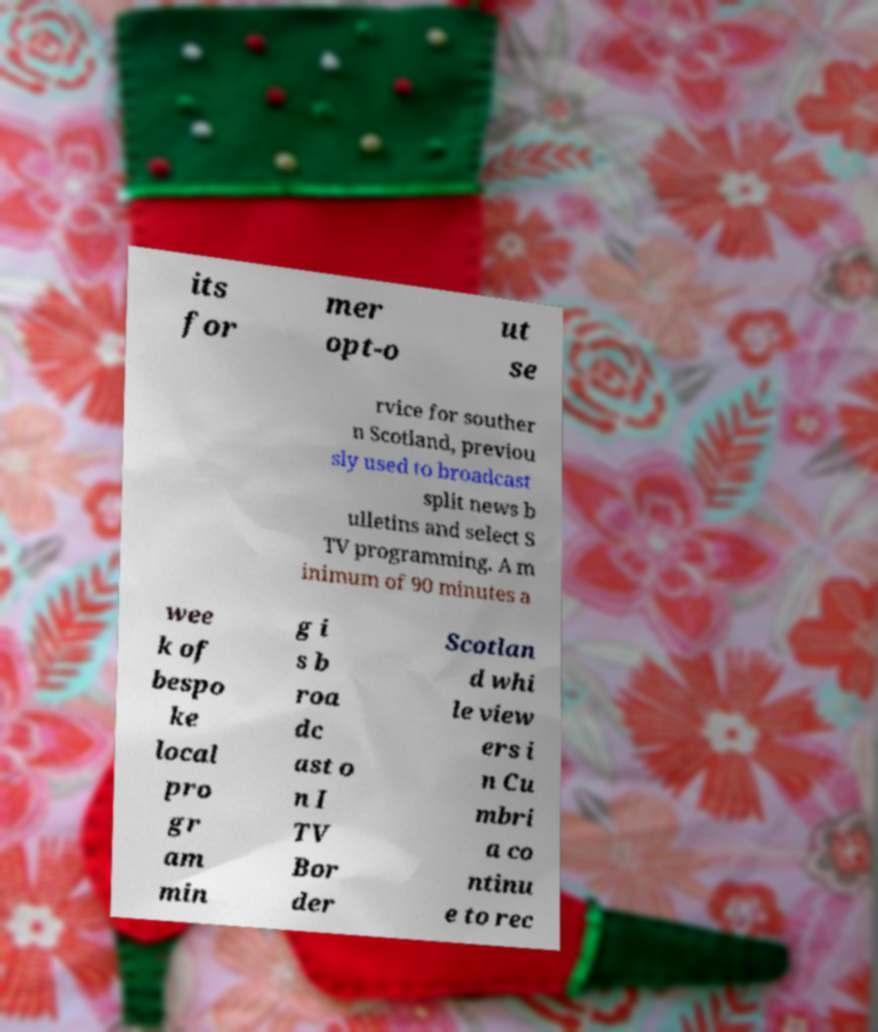Can you read and provide the text displayed in the image?This photo seems to have some interesting text. Can you extract and type it out for me? its for mer opt-o ut se rvice for souther n Scotland, previou sly used to broadcast split news b ulletins and select S TV programming. A m inimum of 90 minutes a wee k of bespo ke local pro gr am min g i s b roa dc ast o n I TV Bor der Scotlan d whi le view ers i n Cu mbri a co ntinu e to rec 